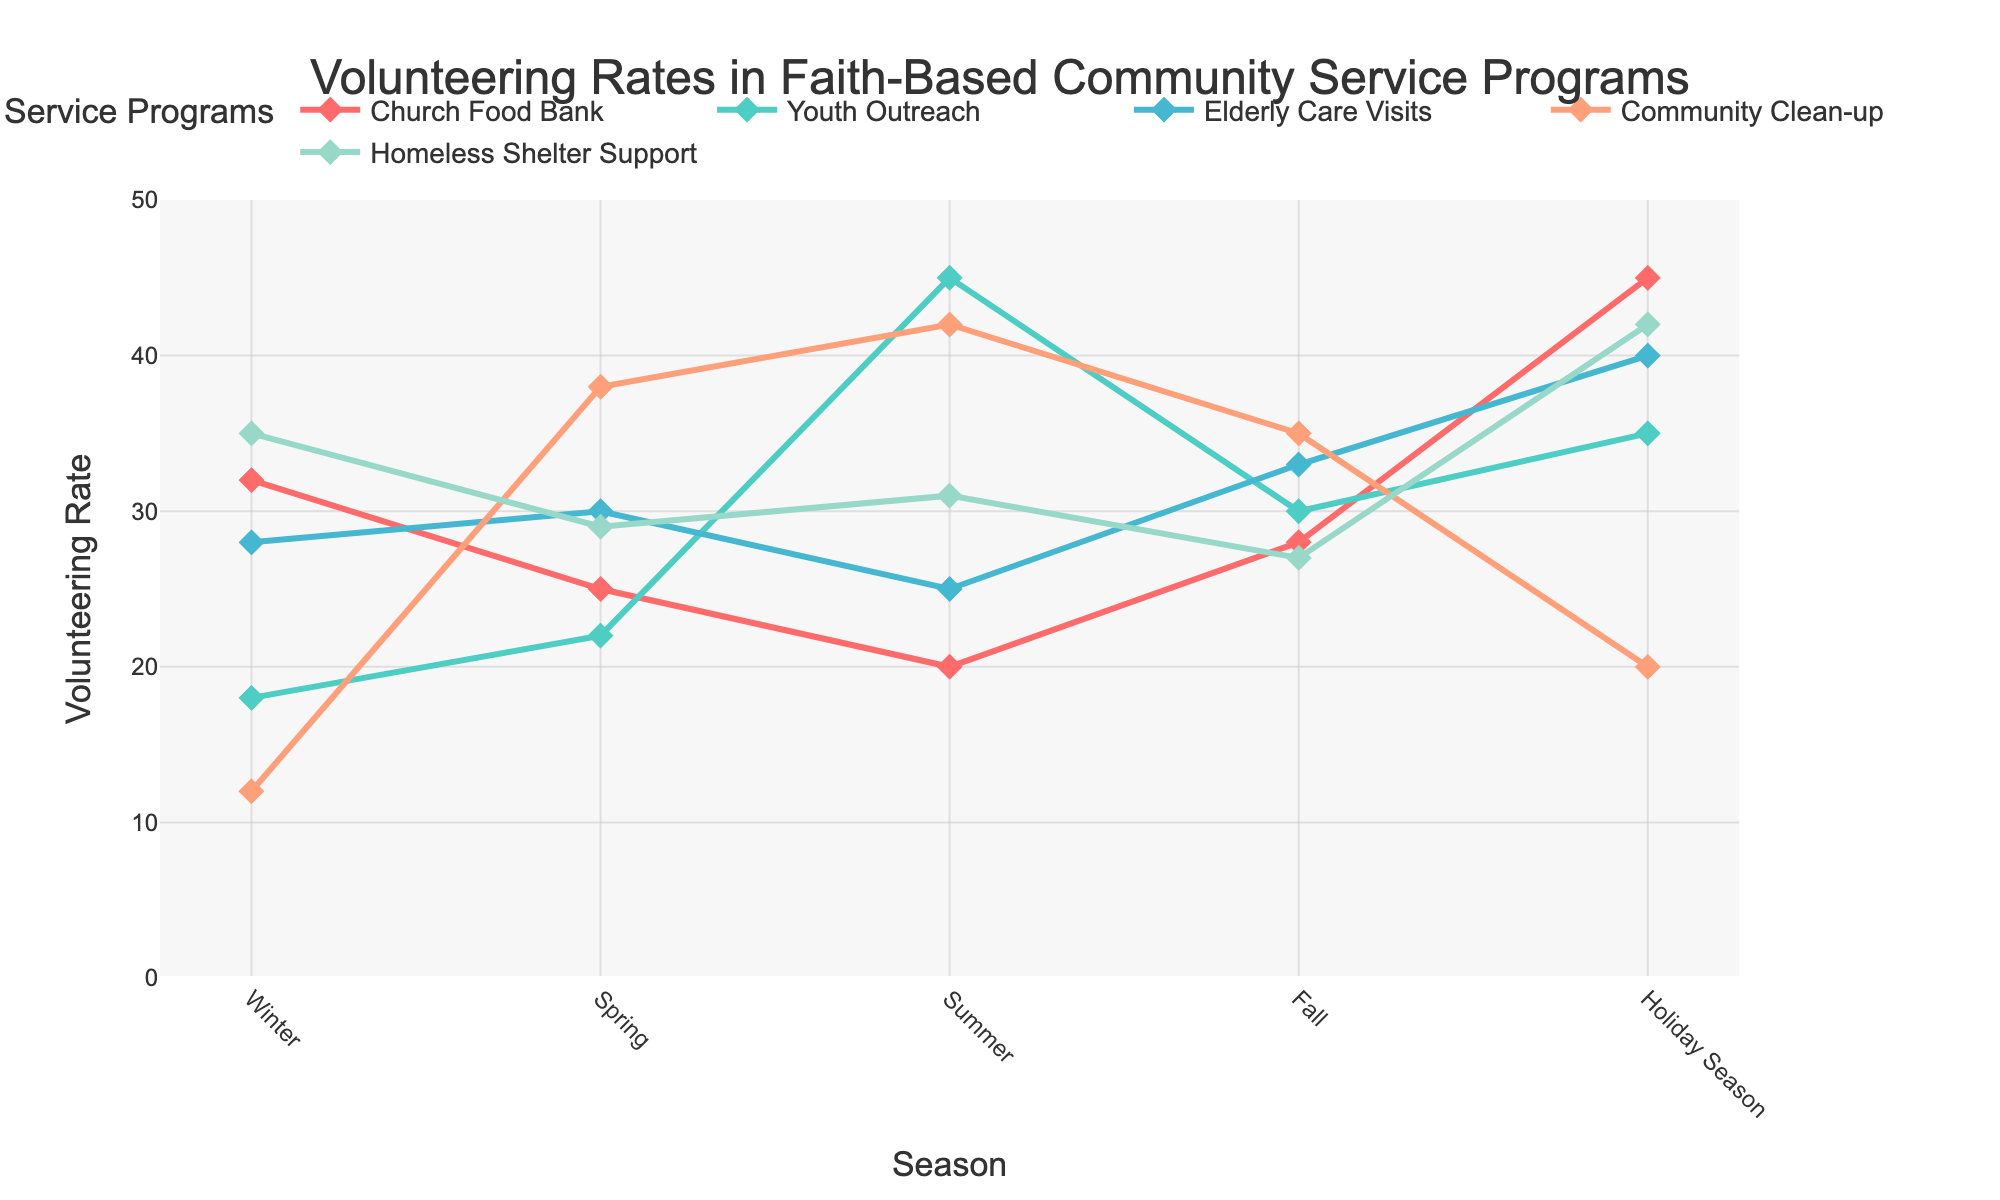What's the volunteering rate for Youth Outreach during the Summer? First, locate Youth Outreach on the plot and then identify the value for Summer. It shows 45.
Answer: 45 Which season has the highest volunteering rate for Church Food Bank? Look at the Church Food Bank line and find the peak point. The highest value is during the Holiday Season at 45.
Answer: Holiday Season Compare the volunteering rates for Elderly Care Visits during Spring and Fall. Which is higher? Find the Elderly Care Visits line and read the values for Spring and Fall. Spring has 30 and Fall has 33, so Fall is higher.
Answer: Fall What is the average volunteering rate for Homeless Shelter Support across all seasons? Sum the values of Homeless Shelter Support for all seasons (35 + 29 + 31 + 27 + 42 = 164) and divide by the number of seasons (5). The average is 164/5 = 32.8.
Answer: 32.8 Is the volunteering rate for Community Clean-up greater in Summer or Spring? Compare the values for Community Clean-up in Summer (42) and Spring (38). Summer is greater.
Answer: Summer What is the difference in the volunteering rate for Church Food Bank between Winter and Summer? Find the values for Winter (32) and Summer (20) and calculate the difference: 32 - 20 = 12.
Answer: 12 During which season does Youth Outreach experience the highest increase in volunteering rate compared to the previous season? Calculate the difference in Youth Outreach rates between consecutive seasons: Winter to Spring (22 - 18 = 4), Spring to Summer (45 - 22 = 23), Summer to Fall (30 - 45 = -15), Fall to Holiday Season (35 - 30 = 5). The highest positive change is from Spring to Summer (23).
Answer: Spring to Summer What is the total volunteering rate for Elderly Care Visits and Community Clean-up during the Fall? Sum the values of Elderly Care Visits (33) and Community Clean-up (35) for Fall: 33 + 35 = 68.
Answer: 68 Which two seasons have the most similar volunteering rates for Youth Outreach? Compare the values: Winter (18), Spring (22), Summer (45), Fall (30), Holiday Season (35). The closest values are Spring (22) and Winter (18), having a small difference of 4.
Answer: Winter and Spring What color is used to represent Homeless Shelter Support? Look at the legend and identify the color associated with Homeless Shelter Support. It is shown in a shade of blue.
Answer: blue 